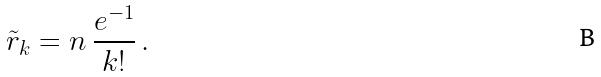Convert formula to latex. <formula><loc_0><loc_0><loc_500><loc_500>\, \tilde { r } _ { k } = n \, \frac { e ^ { - 1 } } { k ! } \, . \,</formula> 